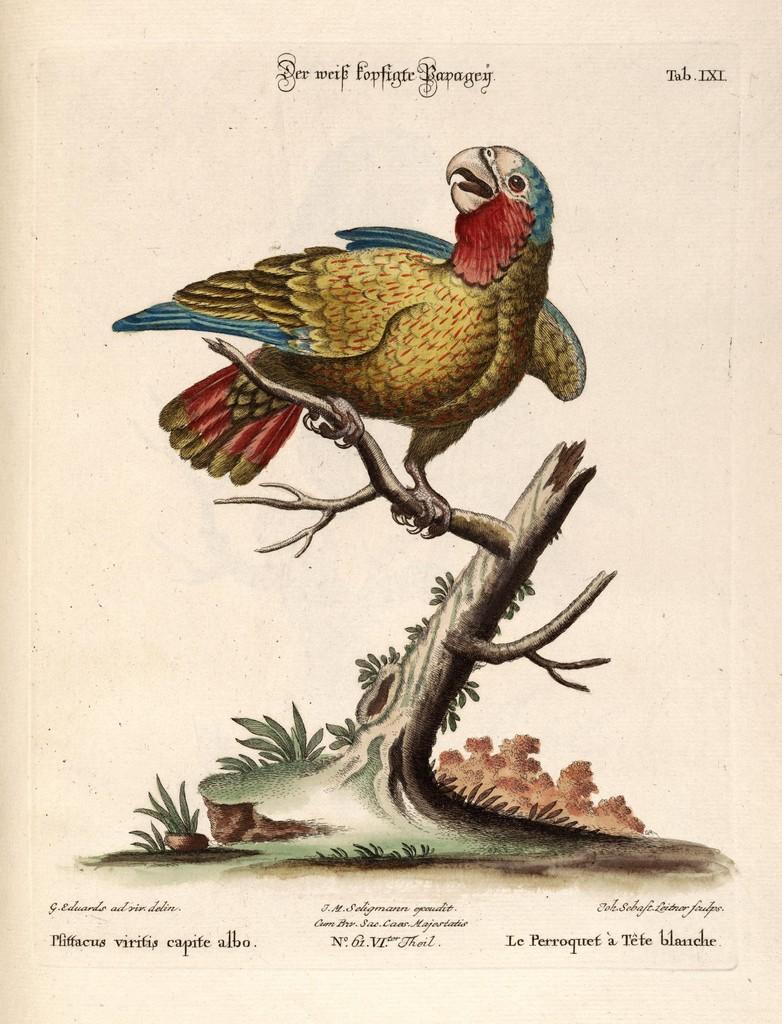How would you summarize this image in a sentence or two? In this image there is a painting of an eagle on a plant, at the bottom and top there is some text. 